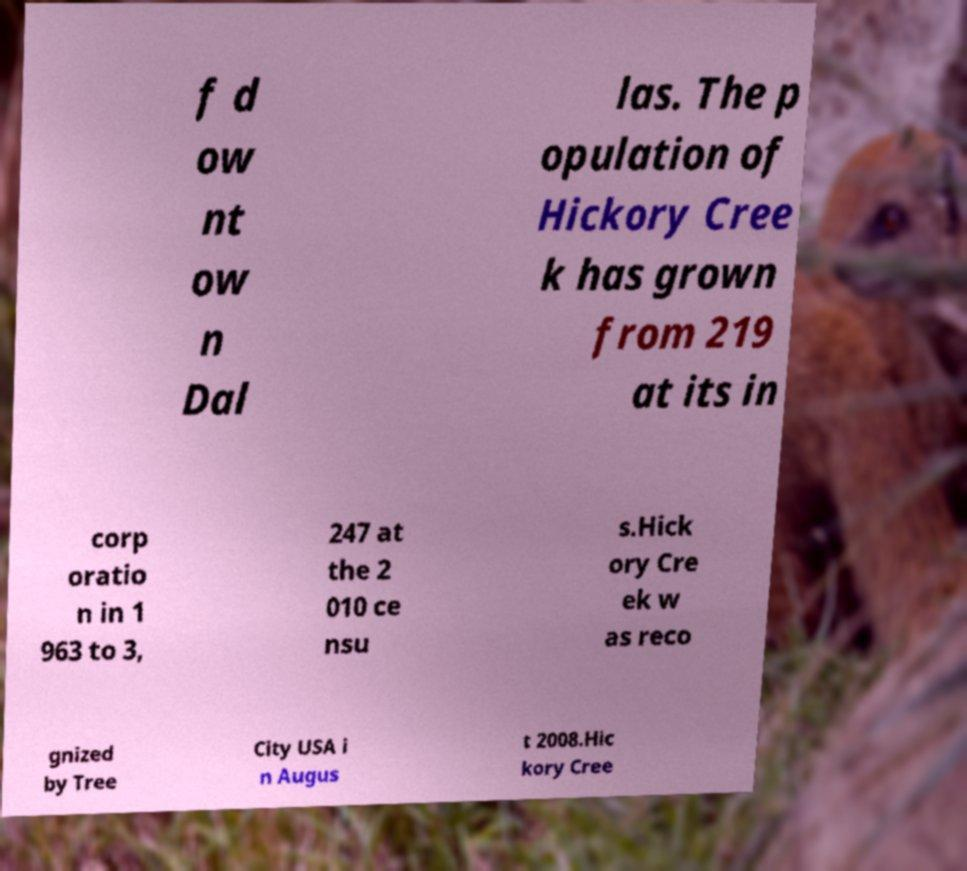Please read and relay the text visible in this image. What does it say? f d ow nt ow n Dal las. The p opulation of Hickory Cree k has grown from 219 at its in corp oratio n in 1 963 to 3, 247 at the 2 010 ce nsu s.Hick ory Cre ek w as reco gnized by Tree City USA i n Augus t 2008.Hic kory Cree 